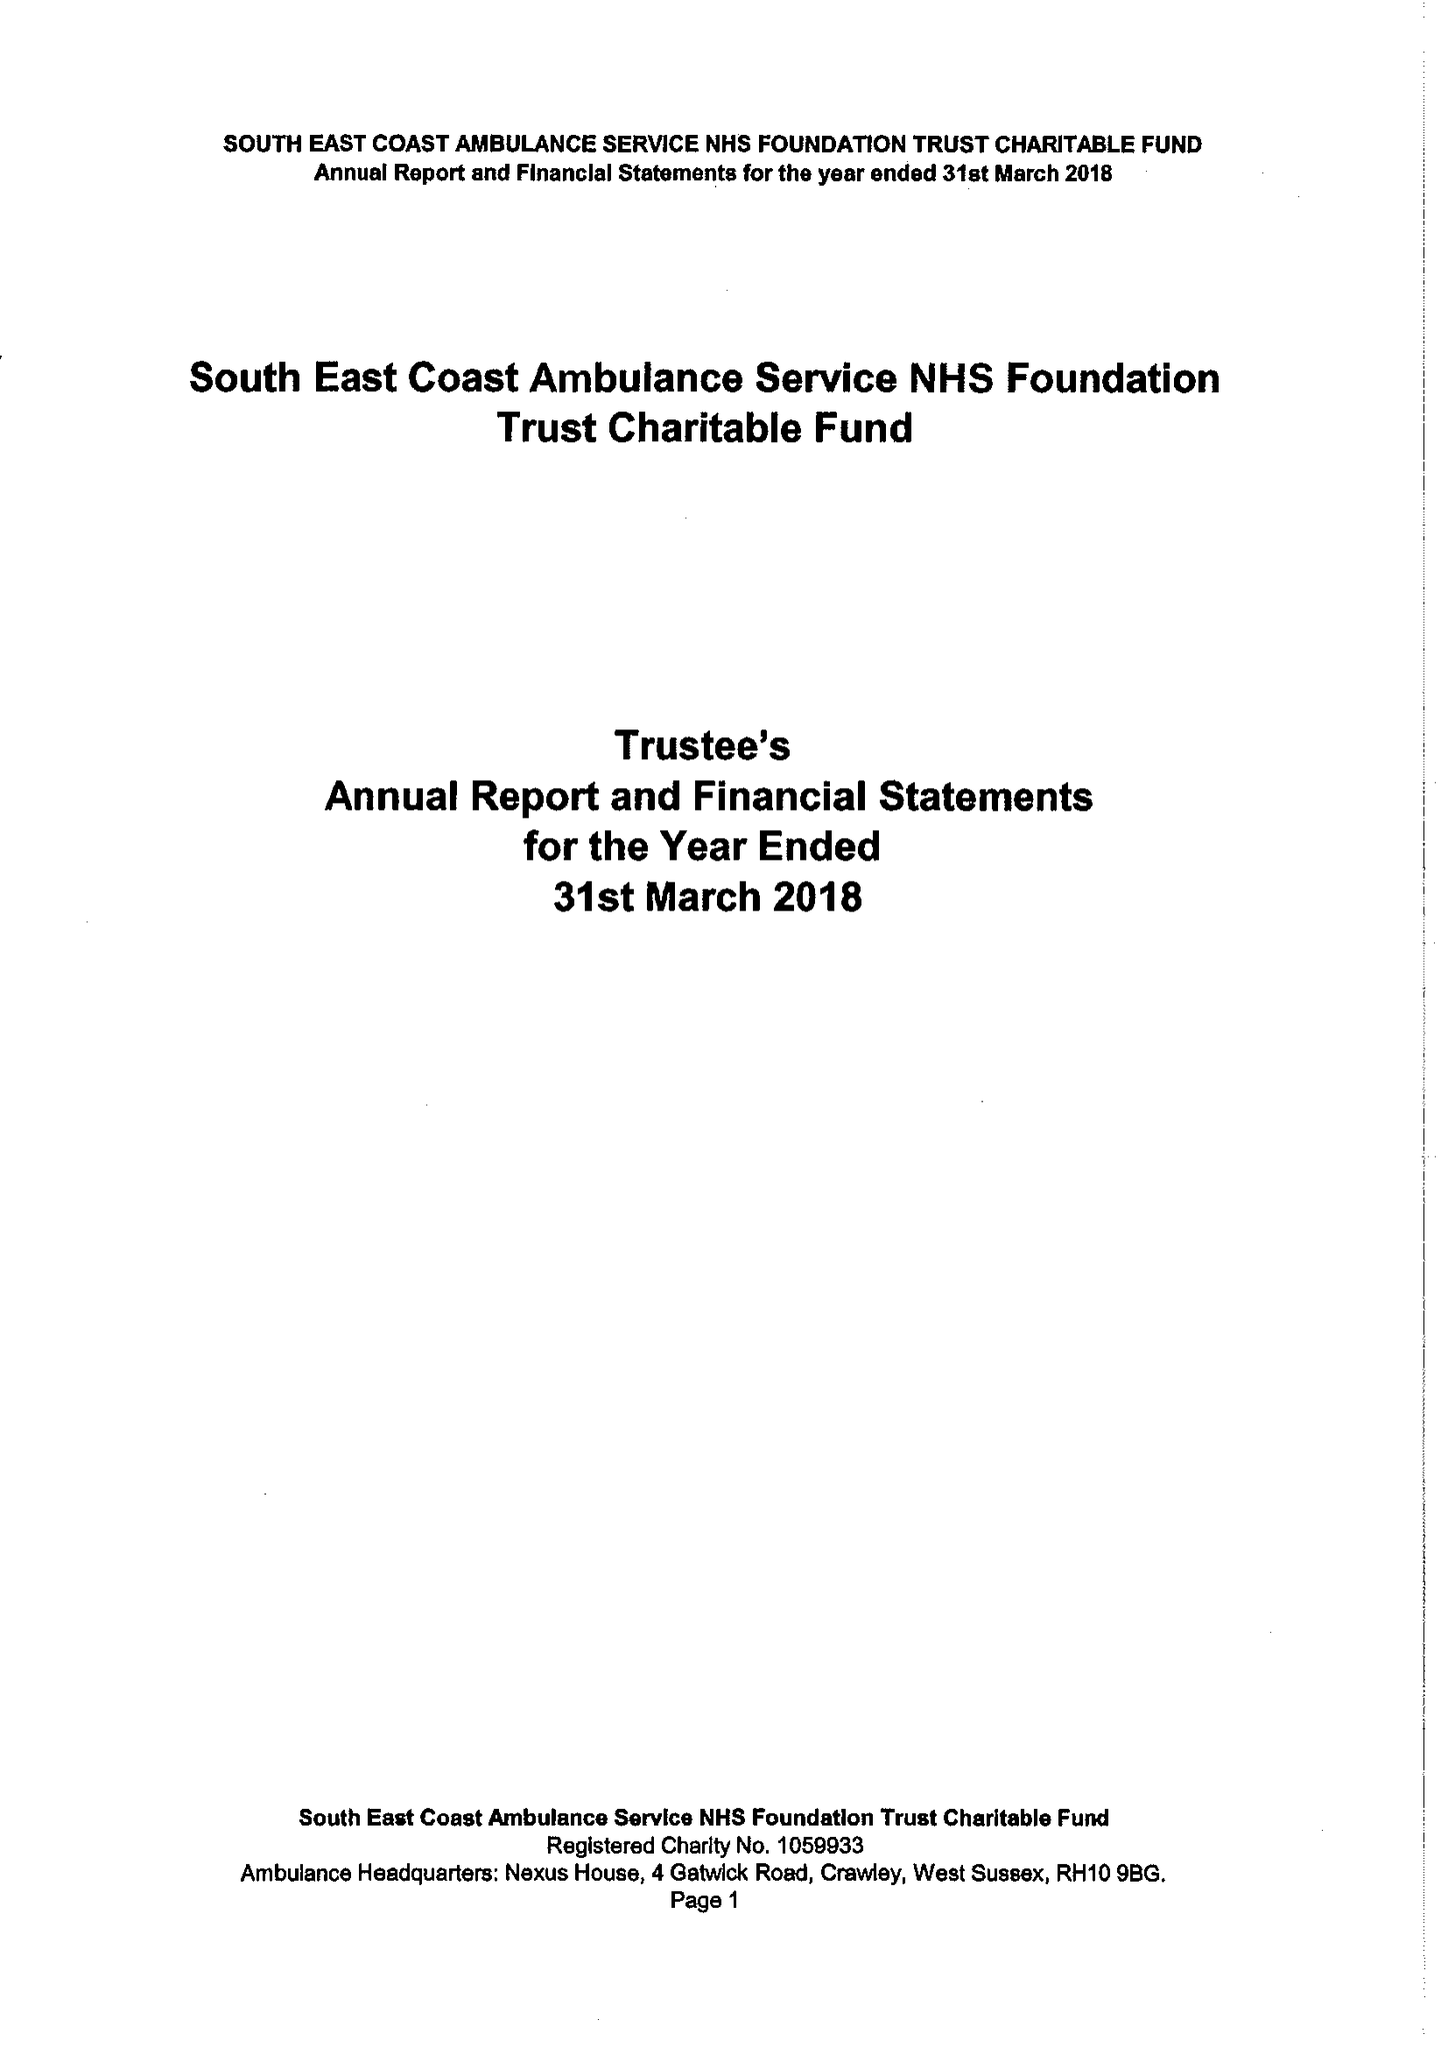What is the value for the charity_name?
Answer the question using a single word or phrase. South East Coast Ambulance Service Nhs Foundation Trust Charitable Fund 